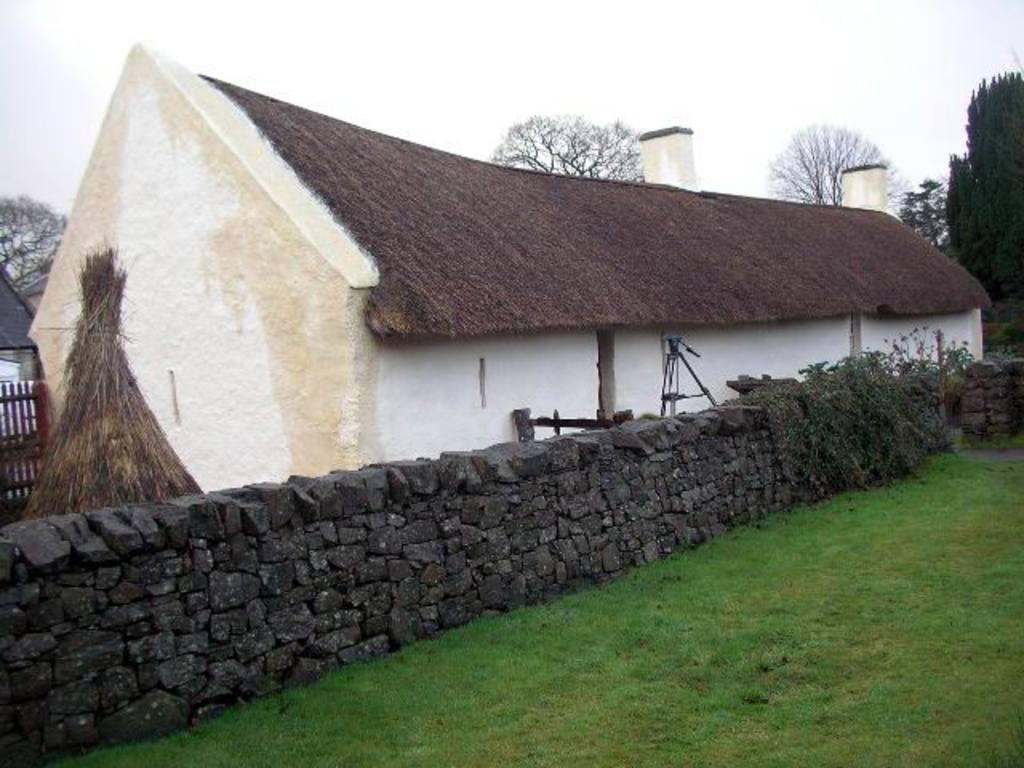What type of surface is on the ground in the image? There is grass on the ground in the image. What type of barrier is present in the image? There is fencing in the image. What type of structure can be seen in the image? There is a house in the image. What type of construction material is used for the wall in the image? There is a stone wall in the image. What type of vegetation is present in the image? There are trees in the image. What other objects can be seen in the image? There are other objects in the image, but their specific details are not mentioned in the provided facts. What is visible in the sky in the image? The sky is visible in the image. How much money is being exchanged between the people in the image? There are no people or money exchange depicted in the image. What type of shoes are the people wearing in the image? There are no people or shoes present in the image. 